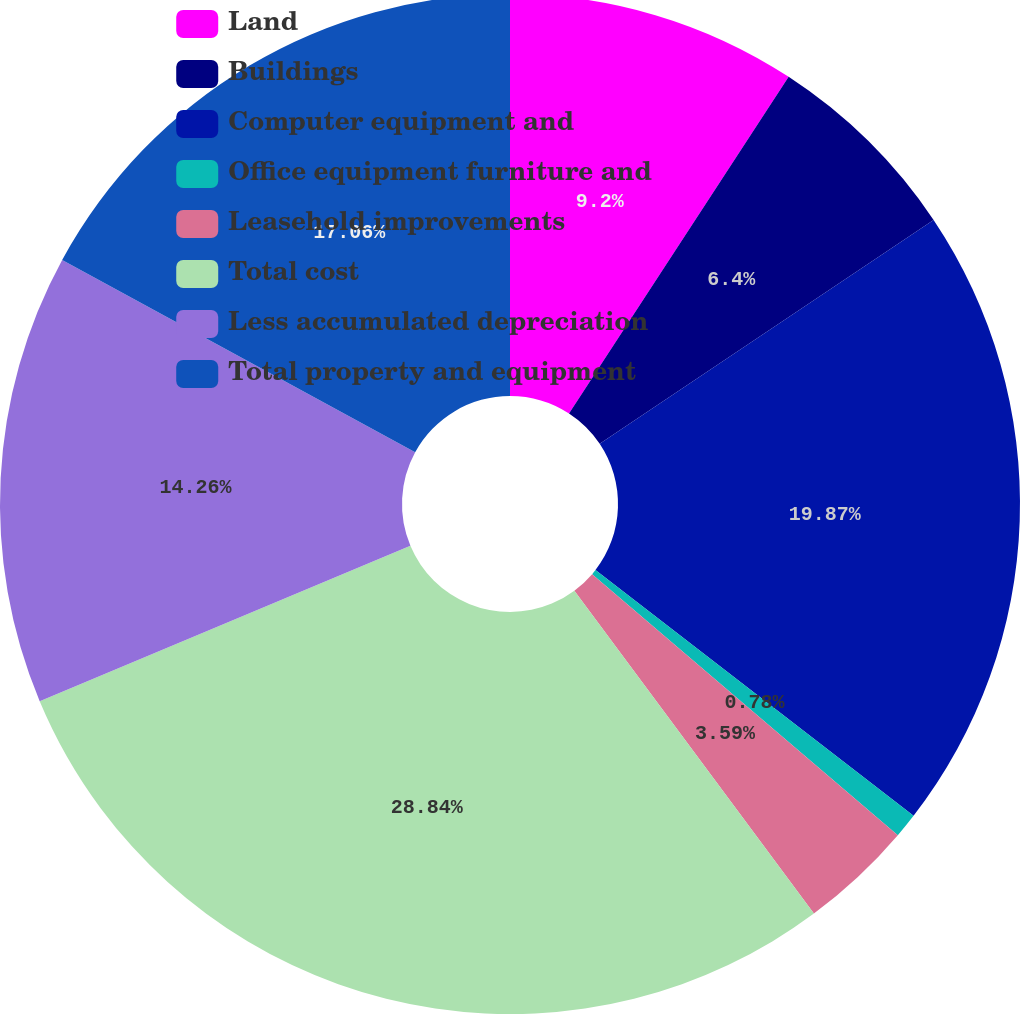<chart> <loc_0><loc_0><loc_500><loc_500><pie_chart><fcel>Land<fcel>Buildings<fcel>Computer equipment and<fcel>Office equipment furniture and<fcel>Leasehold improvements<fcel>Total cost<fcel>Less accumulated depreciation<fcel>Total property and equipment<nl><fcel>9.2%<fcel>6.4%<fcel>19.87%<fcel>0.78%<fcel>3.59%<fcel>28.84%<fcel>14.26%<fcel>17.06%<nl></chart> 